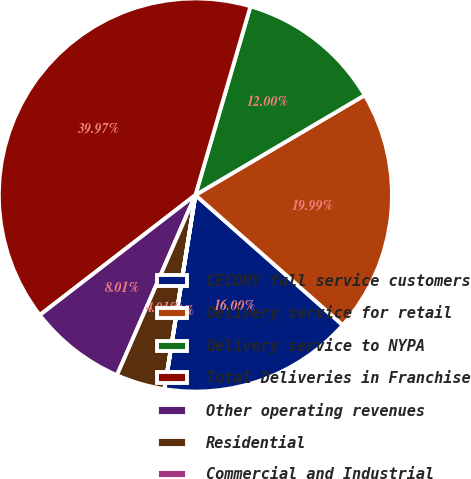Convert chart to OTSL. <chart><loc_0><loc_0><loc_500><loc_500><pie_chart><fcel>CECONY full service customers<fcel>Delivery service for retail<fcel>Delivery service to NYPA<fcel>Total Deliveries in Franchise<fcel>Other operating revenues<fcel>Residential<fcel>Commercial and Industrial<nl><fcel>16.0%<fcel>19.99%<fcel>12.0%<fcel>39.97%<fcel>8.01%<fcel>4.01%<fcel>0.01%<nl></chart> 